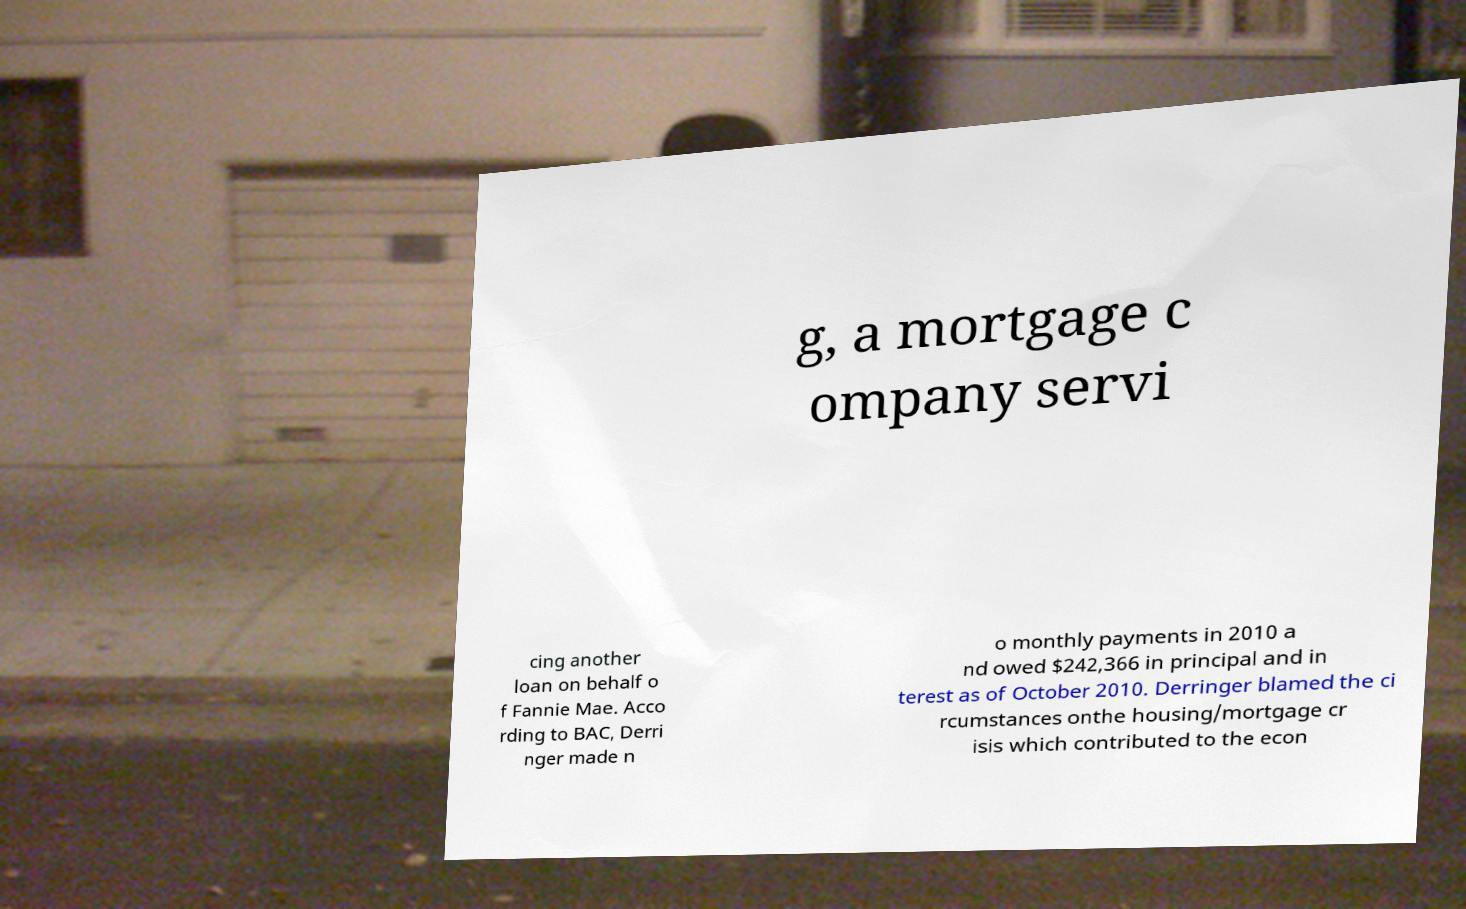I need the written content from this picture converted into text. Can you do that? g, a mortgage c ompany servi cing another loan on behalf o f Fannie Mae. Acco rding to BAC, Derri nger made n o monthly payments in 2010 a nd owed $242,366 in principal and in terest as of October 2010. Derringer blamed the ci rcumstances onthe housing/mortgage cr isis which contributed to the econ 